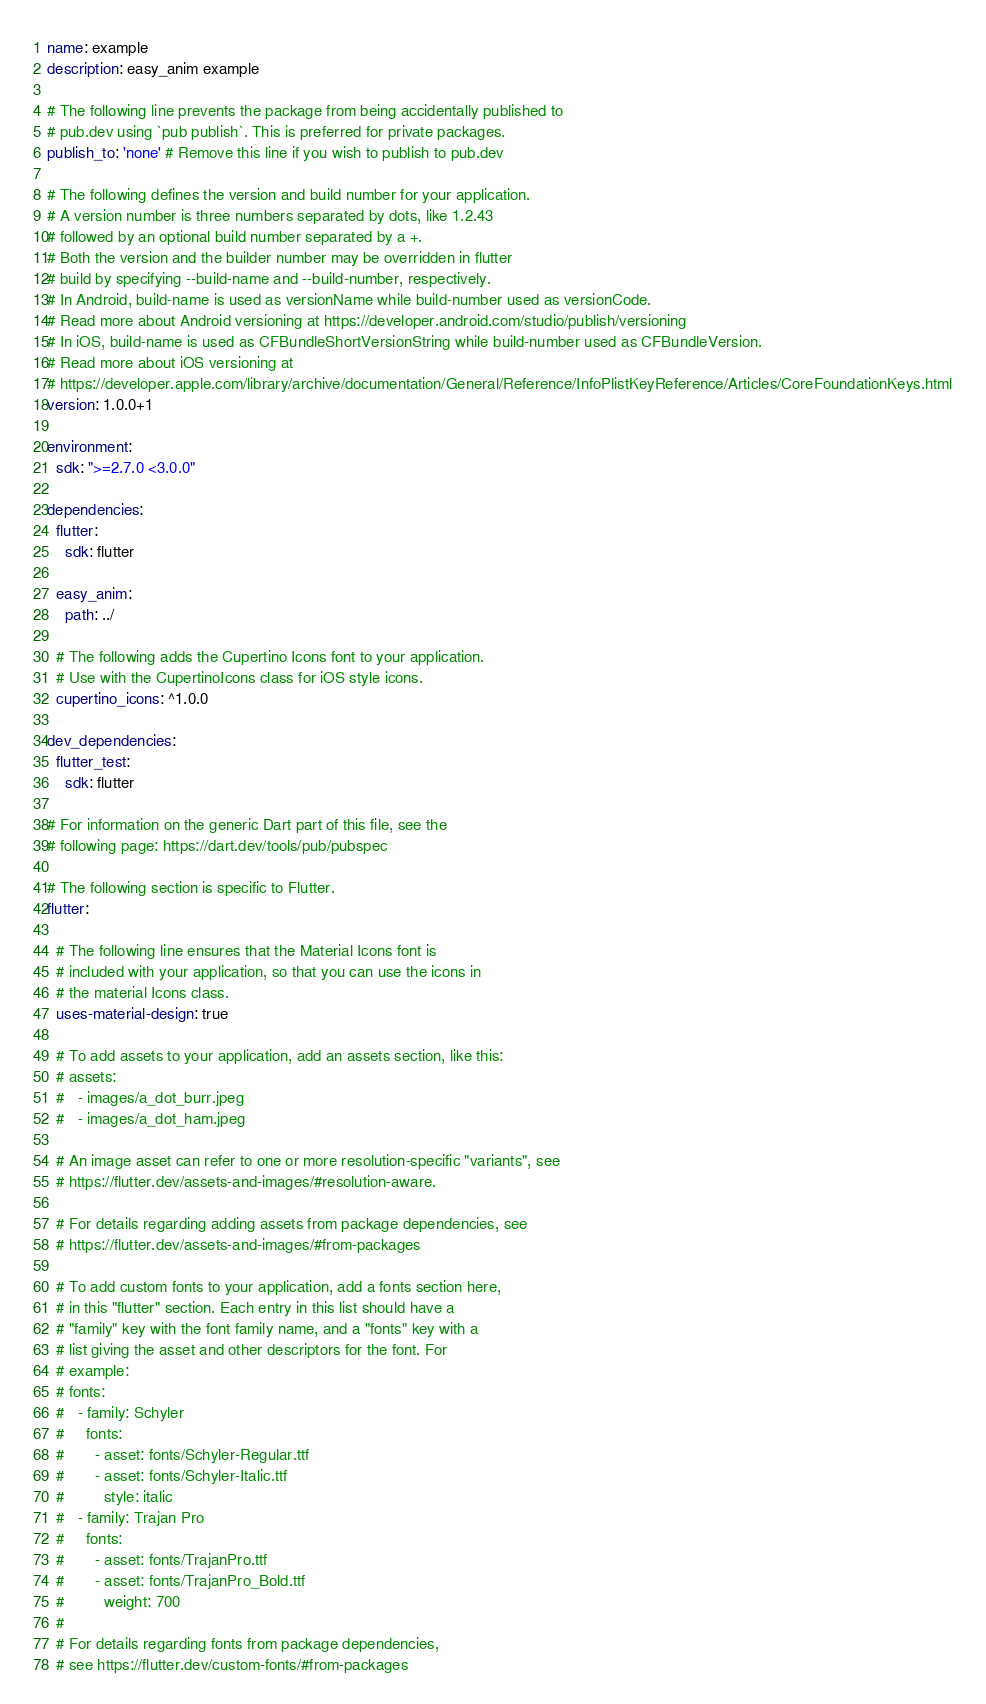Convert code to text. <code><loc_0><loc_0><loc_500><loc_500><_YAML_>name: example
description: easy_anim example

# The following line prevents the package from being accidentally published to
# pub.dev using `pub publish`. This is preferred for private packages.
publish_to: 'none' # Remove this line if you wish to publish to pub.dev

# The following defines the version and build number for your application.
# A version number is three numbers separated by dots, like 1.2.43
# followed by an optional build number separated by a +.
# Both the version and the builder number may be overridden in flutter
# build by specifying --build-name and --build-number, respectively.
# In Android, build-name is used as versionName while build-number used as versionCode.
# Read more about Android versioning at https://developer.android.com/studio/publish/versioning
# In iOS, build-name is used as CFBundleShortVersionString while build-number used as CFBundleVersion.
# Read more about iOS versioning at
# https://developer.apple.com/library/archive/documentation/General/Reference/InfoPlistKeyReference/Articles/CoreFoundationKeys.html
version: 1.0.0+1

environment:
  sdk: ">=2.7.0 <3.0.0"

dependencies:
  flutter:
    sdk: flutter

  easy_anim:
    path: ../

  # The following adds the Cupertino Icons font to your application.
  # Use with the CupertinoIcons class for iOS style icons.
  cupertino_icons: ^1.0.0

dev_dependencies:
  flutter_test:
    sdk: flutter

# For information on the generic Dart part of this file, see the
# following page: https://dart.dev/tools/pub/pubspec

# The following section is specific to Flutter.
flutter:

  # The following line ensures that the Material Icons font is
  # included with your application, so that you can use the icons in
  # the material Icons class.
  uses-material-design: true

  # To add assets to your application, add an assets section, like this:
  # assets:
  #   - images/a_dot_burr.jpeg
  #   - images/a_dot_ham.jpeg

  # An image asset can refer to one or more resolution-specific "variants", see
  # https://flutter.dev/assets-and-images/#resolution-aware.

  # For details regarding adding assets from package dependencies, see
  # https://flutter.dev/assets-and-images/#from-packages

  # To add custom fonts to your application, add a fonts section here,
  # in this "flutter" section. Each entry in this list should have a
  # "family" key with the font family name, and a "fonts" key with a
  # list giving the asset and other descriptors for the font. For
  # example:
  # fonts:
  #   - family: Schyler
  #     fonts:
  #       - asset: fonts/Schyler-Regular.ttf
  #       - asset: fonts/Schyler-Italic.ttf
  #         style: italic
  #   - family: Trajan Pro
  #     fonts:
  #       - asset: fonts/TrajanPro.ttf
  #       - asset: fonts/TrajanPro_Bold.ttf
  #         weight: 700
  #
  # For details regarding fonts from package dependencies,
  # see https://flutter.dev/custom-fonts/#from-packages
</code> 